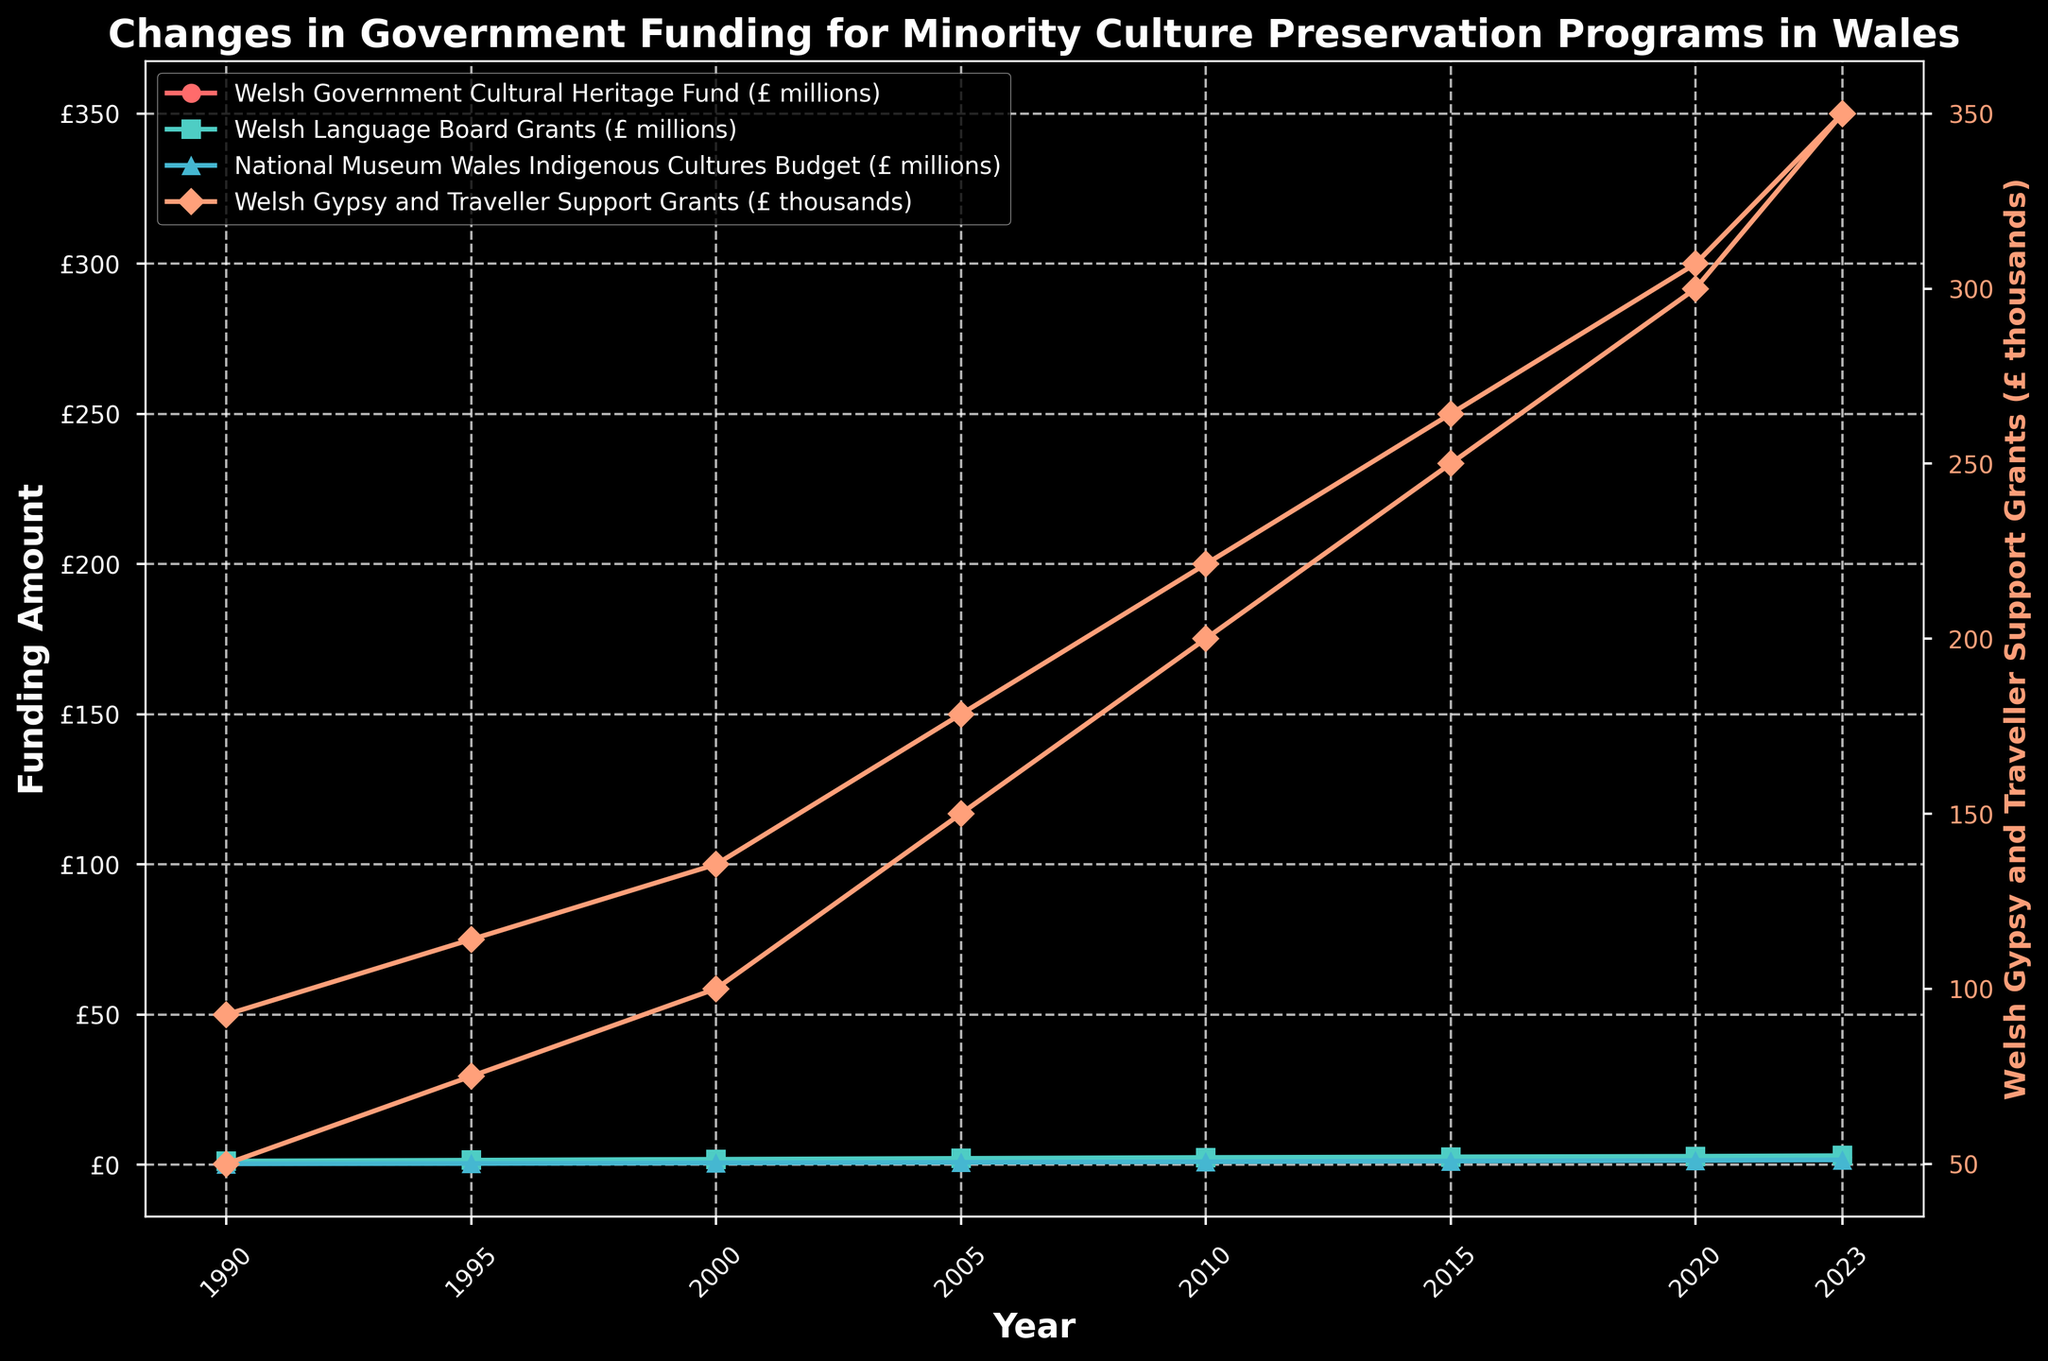What is the highest amount of funding received by the Welsh Language Board Grants during the period shown? The highest point on the plot for the Welsh Language Board Grants line is at the year 2023, where the value reaches £3.0 million.
Answer: £3.0 million How did the Welsh Government Cultural Heritage Fund change from 1990 to 2023? In 1990, the funding was £0.5 million, and it increased to £2.5 million by 2023. The change can be calculated as £2.5 million - £0.5 million, which equals £2.0 million.
Answer: Increased by £2.0 million Which funding category has shown the most significant increase in absolute terms since 1990? Comparing the increase in all categories: Welsh Government Cultural Heritage Fund from £0.5 million to £2.5 million (+£2.0 million), Welsh Language Board Grants from £1.2 million to £3.0 million (+£1.8 million), National Museum Wales Indigenous Cultures Budget from £0.3 million to £1.6 million (+£1.3 million), and Welsh Gypsy and Traveller Support Grants from £50 thousand to £350 thousand (+£300 thousand). The Welsh Government Cultural Heritage Fund shows the highest increase of £2.0 million.
Answer: Welsh Government Cultural Heritage Fund Between which years did the National Museum Wales Indigenous Cultures Budget experience the sharpest rise? Checking the year-to-year increases: 1990 to 1995 (+£0.1 million), 1995 to 2000 (+£0.2 million), 2000 to 2005 (+£0.2 million), 2005 to 2010 (+£0.2 million), 2010 to 2015 (+£0.2 million), and 2015 to 2020 (+£0.2 million). The sharpest rise in a single period is from 1995 to 2000 and several others that increased by £0.2 million.
Answer: 1995 to 2000 (and others) What was the average annual funding for the Welsh Gypsy and Traveller Support Grants over the period from 1990 to 2023? Summing the values for the years: (£50 + £75 + £100 + £150 + £200 + £250 + £300 + £350) thousand = £1475 thousand. Dividing by the number of data points (8 years): £1475 thousand / 8 = £184.375 thousand (approximately £184.4 thousand when rounded).
Answer: £184.4 thousand In which year did the funding for the Welsh Government Cultural Heritage Fund first surpass £1 million? Observing the plot, the Welsh Government Cultural Heritage Fund first surpasses £1 million in the year 2000, where it stands at £1.2 million.
Answer: 2000 Compare the growth trends of the Welsh Language Board Grants and the National Museum Wales Indigenous Cultures Budget from 1990 to 2023. Which has grown at a faster rate? From 1990 to 2023, the Welsh Language Board Grants increased from £1.2 million to £3.0 million (+£1.8 million), while the National Museum Wales Indigenous Cultures Budget grew from £0.3 million to £1.6 million (+£1.3 million). The Welsh Language Board Grants has grown at a faster rate in absolute terms with a total increase of £1.8 million compared to £1.3 million for the National Museum Wales Indigenous Cultures Budget.
Answer: Welsh Language Board Grants 